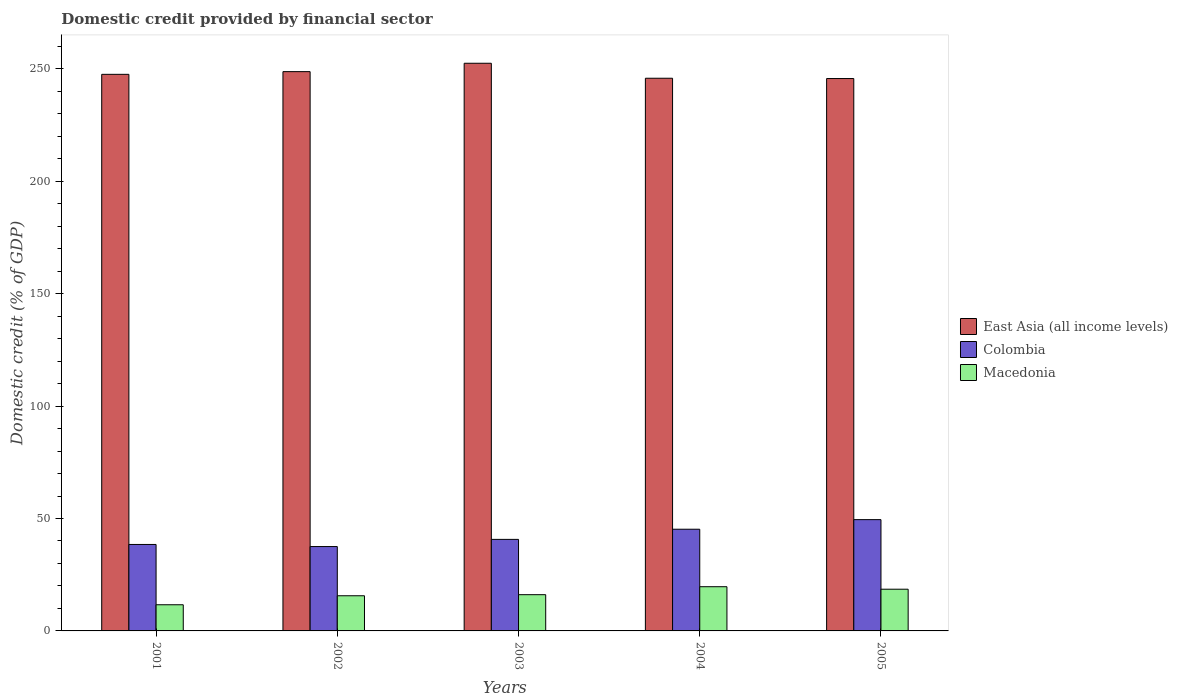Are the number of bars per tick equal to the number of legend labels?
Ensure brevity in your answer.  Yes. How many bars are there on the 2nd tick from the left?
Offer a very short reply. 3. How many bars are there on the 3rd tick from the right?
Give a very brief answer. 3. In how many cases, is the number of bars for a given year not equal to the number of legend labels?
Make the answer very short. 0. What is the domestic credit in East Asia (all income levels) in 2001?
Keep it short and to the point. 247.56. Across all years, what is the maximum domestic credit in Macedonia?
Provide a short and direct response. 19.66. Across all years, what is the minimum domestic credit in Colombia?
Your answer should be very brief. 37.53. What is the total domestic credit in East Asia (all income levels) in the graph?
Your response must be concise. 1240.33. What is the difference between the domestic credit in Macedonia in 2001 and that in 2002?
Offer a terse response. -4. What is the difference between the domestic credit in Macedonia in 2005 and the domestic credit in East Asia (all income levels) in 2002?
Your answer should be compact. -230.21. What is the average domestic credit in Macedonia per year?
Keep it short and to the point. 16.32. In the year 2004, what is the difference between the domestic credit in Colombia and domestic credit in East Asia (all income levels)?
Your answer should be compact. -200.59. What is the ratio of the domestic credit in Macedonia in 2002 to that in 2004?
Your response must be concise. 0.8. Is the domestic credit in East Asia (all income levels) in 2003 less than that in 2005?
Your answer should be very brief. No. What is the difference between the highest and the second highest domestic credit in Colombia?
Make the answer very short. 4.27. What is the difference between the highest and the lowest domestic credit in East Asia (all income levels)?
Your answer should be compact. 6.8. In how many years, is the domestic credit in East Asia (all income levels) greater than the average domestic credit in East Asia (all income levels) taken over all years?
Provide a short and direct response. 2. What does the 3rd bar from the left in 2003 represents?
Provide a short and direct response. Macedonia. What does the 1st bar from the right in 2004 represents?
Offer a terse response. Macedonia. Is it the case that in every year, the sum of the domestic credit in East Asia (all income levels) and domestic credit in Colombia is greater than the domestic credit in Macedonia?
Provide a short and direct response. Yes. How many bars are there?
Your answer should be very brief. 15. Are all the bars in the graph horizontal?
Your answer should be very brief. No. Are the values on the major ticks of Y-axis written in scientific E-notation?
Give a very brief answer. No. Does the graph contain any zero values?
Your response must be concise. No. How are the legend labels stacked?
Offer a very short reply. Vertical. What is the title of the graph?
Make the answer very short. Domestic credit provided by financial sector. Does "Nigeria" appear as one of the legend labels in the graph?
Keep it short and to the point. No. What is the label or title of the Y-axis?
Offer a very short reply. Domestic credit (% of GDP). What is the Domestic credit (% of GDP) in East Asia (all income levels) in 2001?
Your answer should be very brief. 247.56. What is the Domestic credit (% of GDP) of Colombia in 2001?
Provide a succinct answer. 38.46. What is the Domestic credit (% of GDP) of Macedonia in 2001?
Ensure brevity in your answer.  11.64. What is the Domestic credit (% of GDP) in East Asia (all income levels) in 2002?
Your answer should be compact. 248.76. What is the Domestic credit (% of GDP) in Colombia in 2002?
Your answer should be compact. 37.53. What is the Domestic credit (% of GDP) of Macedonia in 2002?
Your response must be concise. 15.64. What is the Domestic credit (% of GDP) of East Asia (all income levels) in 2003?
Keep it short and to the point. 252.49. What is the Domestic credit (% of GDP) of Colombia in 2003?
Offer a terse response. 40.72. What is the Domestic credit (% of GDP) of Macedonia in 2003?
Provide a short and direct response. 16.12. What is the Domestic credit (% of GDP) of East Asia (all income levels) in 2004?
Provide a short and direct response. 245.82. What is the Domestic credit (% of GDP) in Colombia in 2004?
Make the answer very short. 45.23. What is the Domestic credit (% of GDP) in Macedonia in 2004?
Your answer should be compact. 19.66. What is the Domestic credit (% of GDP) of East Asia (all income levels) in 2005?
Provide a succinct answer. 245.69. What is the Domestic credit (% of GDP) in Colombia in 2005?
Ensure brevity in your answer.  49.5. What is the Domestic credit (% of GDP) of Macedonia in 2005?
Keep it short and to the point. 18.55. Across all years, what is the maximum Domestic credit (% of GDP) in East Asia (all income levels)?
Provide a succinct answer. 252.49. Across all years, what is the maximum Domestic credit (% of GDP) in Colombia?
Make the answer very short. 49.5. Across all years, what is the maximum Domestic credit (% of GDP) of Macedonia?
Offer a terse response. 19.66. Across all years, what is the minimum Domestic credit (% of GDP) in East Asia (all income levels)?
Your response must be concise. 245.69. Across all years, what is the minimum Domestic credit (% of GDP) of Colombia?
Provide a short and direct response. 37.53. Across all years, what is the minimum Domestic credit (% of GDP) in Macedonia?
Ensure brevity in your answer.  11.64. What is the total Domestic credit (% of GDP) of East Asia (all income levels) in the graph?
Give a very brief answer. 1240.33. What is the total Domestic credit (% of GDP) in Colombia in the graph?
Offer a terse response. 211.44. What is the total Domestic credit (% of GDP) in Macedonia in the graph?
Keep it short and to the point. 81.62. What is the difference between the Domestic credit (% of GDP) in East Asia (all income levels) in 2001 and that in 2002?
Make the answer very short. -1.21. What is the difference between the Domestic credit (% of GDP) of Colombia in 2001 and that in 2002?
Provide a short and direct response. 0.93. What is the difference between the Domestic credit (% of GDP) in Macedonia in 2001 and that in 2002?
Offer a very short reply. -4. What is the difference between the Domestic credit (% of GDP) of East Asia (all income levels) in 2001 and that in 2003?
Make the answer very short. -4.93. What is the difference between the Domestic credit (% of GDP) in Colombia in 2001 and that in 2003?
Your response must be concise. -2.26. What is the difference between the Domestic credit (% of GDP) in Macedonia in 2001 and that in 2003?
Offer a very short reply. -4.48. What is the difference between the Domestic credit (% of GDP) of East Asia (all income levels) in 2001 and that in 2004?
Offer a very short reply. 1.74. What is the difference between the Domestic credit (% of GDP) of Colombia in 2001 and that in 2004?
Offer a very short reply. -6.78. What is the difference between the Domestic credit (% of GDP) in Macedonia in 2001 and that in 2004?
Provide a succinct answer. -8.02. What is the difference between the Domestic credit (% of GDP) of East Asia (all income levels) in 2001 and that in 2005?
Your answer should be compact. 1.87. What is the difference between the Domestic credit (% of GDP) in Colombia in 2001 and that in 2005?
Provide a short and direct response. -11.04. What is the difference between the Domestic credit (% of GDP) in Macedonia in 2001 and that in 2005?
Your response must be concise. -6.92. What is the difference between the Domestic credit (% of GDP) in East Asia (all income levels) in 2002 and that in 2003?
Make the answer very short. -3.72. What is the difference between the Domestic credit (% of GDP) in Colombia in 2002 and that in 2003?
Ensure brevity in your answer.  -3.19. What is the difference between the Domestic credit (% of GDP) of Macedonia in 2002 and that in 2003?
Make the answer very short. -0.48. What is the difference between the Domestic credit (% of GDP) in East Asia (all income levels) in 2002 and that in 2004?
Provide a short and direct response. 2.94. What is the difference between the Domestic credit (% of GDP) of Colombia in 2002 and that in 2004?
Make the answer very short. -7.71. What is the difference between the Domestic credit (% of GDP) in Macedonia in 2002 and that in 2004?
Your response must be concise. -4.02. What is the difference between the Domestic credit (% of GDP) of East Asia (all income levels) in 2002 and that in 2005?
Make the answer very short. 3.07. What is the difference between the Domestic credit (% of GDP) in Colombia in 2002 and that in 2005?
Ensure brevity in your answer.  -11.97. What is the difference between the Domestic credit (% of GDP) in Macedonia in 2002 and that in 2005?
Keep it short and to the point. -2.91. What is the difference between the Domestic credit (% of GDP) in East Asia (all income levels) in 2003 and that in 2004?
Make the answer very short. 6.67. What is the difference between the Domestic credit (% of GDP) of Colombia in 2003 and that in 2004?
Give a very brief answer. -4.52. What is the difference between the Domestic credit (% of GDP) in Macedonia in 2003 and that in 2004?
Keep it short and to the point. -3.54. What is the difference between the Domestic credit (% of GDP) in East Asia (all income levels) in 2003 and that in 2005?
Provide a short and direct response. 6.8. What is the difference between the Domestic credit (% of GDP) of Colombia in 2003 and that in 2005?
Provide a succinct answer. -8.79. What is the difference between the Domestic credit (% of GDP) in Macedonia in 2003 and that in 2005?
Ensure brevity in your answer.  -2.43. What is the difference between the Domestic credit (% of GDP) of East Asia (all income levels) in 2004 and that in 2005?
Offer a very short reply. 0.13. What is the difference between the Domestic credit (% of GDP) of Colombia in 2004 and that in 2005?
Offer a very short reply. -4.27. What is the difference between the Domestic credit (% of GDP) in Macedonia in 2004 and that in 2005?
Your answer should be very brief. 1.11. What is the difference between the Domestic credit (% of GDP) of East Asia (all income levels) in 2001 and the Domestic credit (% of GDP) of Colombia in 2002?
Give a very brief answer. 210.03. What is the difference between the Domestic credit (% of GDP) of East Asia (all income levels) in 2001 and the Domestic credit (% of GDP) of Macedonia in 2002?
Your answer should be compact. 231.92. What is the difference between the Domestic credit (% of GDP) in Colombia in 2001 and the Domestic credit (% of GDP) in Macedonia in 2002?
Offer a terse response. 22.82. What is the difference between the Domestic credit (% of GDP) of East Asia (all income levels) in 2001 and the Domestic credit (% of GDP) of Colombia in 2003?
Give a very brief answer. 206.84. What is the difference between the Domestic credit (% of GDP) in East Asia (all income levels) in 2001 and the Domestic credit (% of GDP) in Macedonia in 2003?
Offer a very short reply. 231.44. What is the difference between the Domestic credit (% of GDP) in Colombia in 2001 and the Domestic credit (% of GDP) in Macedonia in 2003?
Your response must be concise. 22.34. What is the difference between the Domestic credit (% of GDP) of East Asia (all income levels) in 2001 and the Domestic credit (% of GDP) of Colombia in 2004?
Give a very brief answer. 202.33. What is the difference between the Domestic credit (% of GDP) in East Asia (all income levels) in 2001 and the Domestic credit (% of GDP) in Macedonia in 2004?
Offer a terse response. 227.9. What is the difference between the Domestic credit (% of GDP) in Colombia in 2001 and the Domestic credit (% of GDP) in Macedonia in 2004?
Keep it short and to the point. 18.8. What is the difference between the Domestic credit (% of GDP) in East Asia (all income levels) in 2001 and the Domestic credit (% of GDP) in Colombia in 2005?
Offer a very short reply. 198.06. What is the difference between the Domestic credit (% of GDP) in East Asia (all income levels) in 2001 and the Domestic credit (% of GDP) in Macedonia in 2005?
Offer a terse response. 229. What is the difference between the Domestic credit (% of GDP) of Colombia in 2001 and the Domestic credit (% of GDP) of Macedonia in 2005?
Your response must be concise. 19.9. What is the difference between the Domestic credit (% of GDP) of East Asia (all income levels) in 2002 and the Domestic credit (% of GDP) of Colombia in 2003?
Your response must be concise. 208.05. What is the difference between the Domestic credit (% of GDP) in East Asia (all income levels) in 2002 and the Domestic credit (% of GDP) in Macedonia in 2003?
Provide a succinct answer. 232.64. What is the difference between the Domestic credit (% of GDP) of Colombia in 2002 and the Domestic credit (% of GDP) of Macedonia in 2003?
Your answer should be compact. 21.41. What is the difference between the Domestic credit (% of GDP) in East Asia (all income levels) in 2002 and the Domestic credit (% of GDP) in Colombia in 2004?
Keep it short and to the point. 203.53. What is the difference between the Domestic credit (% of GDP) in East Asia (all income levels) in 2002 and the Domestic credit (% of GDP) in Macedonia in 2004?
Ensure brevity in your answer.  229.1. What is the difference between the Domestic credit (% of GDP) in Colombia in 2002 and the Domestic credit (% of GDP) in Macedonia in 2004?
Ensure brevity in your answer.  17.87. What is the difference between the Domestic credit (% of GDP) of East Asia (all income levels) in 2002 and the Domestic credit (% of GDP) of Colombia in 2005?
Your answer should be compact. 199.26. What is the difference between the Domestic credit (% of GDP) in East Asia (all income levels) in 2002 and the Domestic credit (% of GDP) in Macedonia in 2005?
Ensure brevity in your answer.  230.21. What is the difference between the Domestic credit (% of GDP) of Colombia in 2002 and the Domestic credit (% of GDP) of Macedonia in 2005?
Your answer should be very brief. 18.97. What is the difference between the Domestic credit (% of GDP) of East Asia (all income levels) in 2003 and the Domestic credit (% of GDP) of Colombia in 2004?
Ensure brevity in your answer.  207.26. What is the difference between the Domestic credit (% of GDP) in East Asia (all income levels) in 2003 and the Domestic credit (% of GDP) in Macedonia in 2004?
Provide a succinct answer. 232.83. What is the difference between the Domestic credit (% of GDP) of Colombia in 2003 and the Domestic credit (% of GDP) of Macedonia in 2004?
Provide a short and direct response. 21.05. What is the difference between the Domestic credit (% of GDP) of East Asia (all income levels) in 2003 and the Domestic credit (% of GDP) of Colombia in 2005?
Offer a very short reply. 202.99. What is the difference between the Domestic credit (% of GDP) in East Asia (all income levels) in 2003 and the Domestic credit (% of GDP) in Macedonia in 2005?
Give a very brief answer. 233.93. What is the difference between the Domestic credit (% of GDP) of Colombia in 2003 and the Domestic credit (% of GDP) of Macedonia in 2005?
Provide a short and direct response. 22.16. What is the difference between the Domestic credit (% of GDP) of East Asia (all income levels) in 2004 and the Domestic credit (% of GDP) of Colombia in 2005?
Offer a very short reply. 196.32. What is the difference between the Domestic credit (% of GDP) in East Asia (all income levels) in 2004 and the Domestic credit (% of GDP) in Macedonia in 2005?
Provide a short and direct response. 227.27. What is the difference between the Domestic credit (% of GDP) in Colombia in 2004 and the Domestic credit (% of GDP) in Macedonia in 2005?
Provide a short and direct response. 26.68. What is the average Domestic credit (% of GDP) in East Asia (all income levels) per year?
Offer a very short reply. 248.07. What is the average Domestic credit (% of GDP) in Colombia per year?
Your answer should be very brief. 42.29. What is the average Domestic credit (% of GDP) in Macedonia per year?
Keep it short and to the point. 16.32. In the year 2001, what is the difference between the Domestic credit (% of GDP) of East Asia (all income levels) and Domestic credit (% of GDP) of Colombia?
Ensure brevity in your answer.  209.1. In the year 2001, what is the difference between the Domestic credit (% of GDP) of East Asia (all income levels) and Domestic credit (% of GDP) of Macedonia?
Your response must be concise. 235.92. In the year 2001, what is the difference between the Domestic credit (% of GDP) in Colombia and Domestic credit (% of GDP) in Macedonia?
Offer a very short reply. 26.82. In the year 2002, what is the difference between the Domestic credit (% of GDP) of East Asia (all income levels) and Domestic credit (% of GDP) of Colombia?
Ensure brevity in your answer.  211.24. In the year 2002, what is the difference between the Domestic credit (% of GDP) in East Asia (all income levels) and Domestic credit (% of GDP) in Macedonia?
Provide a short and direct response. 233.12. In the year 2002, what is the difference between the Domestic credit (% of GDP) of Colombia and Domestic credit (% of GDP) of Macedonia?
Make the answer very short. 21.89. In the year 2003, what is the difference between the Domestic credit (% of GDP) in East Asia (all income levels) and Domestic credit (% of GDP) in Colombia?
Ensure brevity in your answer.  211.77. In the year 2003, what is the difference between the Domestic credit (% of GDP) in East Asia (all income levels) and Domestic credit (% of GDP) in Macedonia?
Your answer should be compact. 236.37. In the year 2003, what is the difference between the Domestic credit (% of GDP) in Colombia and Domestic credit (% of GDP) in Macedonia?
Provide a short and direct response. 24.6. In the year 2004, what is the difference between the Domestic credit (% of GDP) in East Asia (all income levels) and Domestic credit (% of GDP) in Colombia?
Provide a succinct answer. 200.59. In the year 2004, what is the difference between the Domestic credit (% of GDP) in East Asia (all income levels) and Domestic credit (% of GDP) in Macedonia?
Keep it short and to the point. 226.16. In the year 2004, what is the difference between the Domestic credit (% of GDP) of Colombia and Domestic credit (% of GDP) of Macedonia?
Make the answer very short. 25.57. In the year 2005, what is the difference between the Domestic credit (% of GDP) of East Asia (all income levels) and Domestic credit (% of GDP) of Colombia?
Your answer should be very brief. 196.19. In the year 2005, what is the difference between the Domestic credit (% of GDP) in East Asia (all income levels) and Domestic credit (% of GDP) in Macedonia?
Your answer should be very brief. 227.14. In the year 2005, what is the difference between the Domestic credit (% of GDP) of Colombia and Domestic credit (% of GDP) of Macedonia?
Your answer should be very brief. 30.95. What is the ratio of the Domestic credit (% of GDP) of Colombia in 2001 to that in 2002?
Provide a succinct answer. 1.02. What is the ratio of the Domestic credit (% of GDP) of Macedonia in 2001 to that in 2002?
Your answer should be very brief. 0.74. What is the ratio of the Domestic credit (% of GDP) of East Asia (all income levels) in 2001 to that in 2003?
Your answer should be very brief. 0.98. What is the ratio of the Domestic credit (% of GDP) of Colombia in 2001 to that in 2003?
Make the answer very short. 0.94. What is the ratio of the Domestic credit (% of GDP) in Macedonia in 2001 to that in 2003?
Your answer should be compact. 0.72. What is the ratio of the Domestic credit (% of GDP) in East Asia (all income levels) in 2001 to that in 2004?
Keep it short and to the point. 1.01. What is the ratio of the Domestic credit (% of GDP) of Colombia in 2001 to that in 2004?
Offer a terse response. 0.85. What is the ratio of the Domestic credit (% of GDP) in Macedonia in 2001 to that in 2004?
Offer a very short reply. 0.59. What is the ratio of the Domestic credit (% of GDP) in East Asia (all income levels) in 2001 to that in 2005?
Give a very brief answer. 1.01. What is the ratio of the Domestic credit (% of GDP) in Colombia in 2001 to that in 2005?
Your answer should be compact. 0.78. What is the ratio of the Domestic credit (% of GDP) of Macedonia in 2001 to that in 2005?
Your answer should be compact. 0.63. What is the ratio of the Domestic credit (% of GDP) of East Asia (all income levels) in 2002 to that in 2003?
Provide a short and direct response. 0.99. What is the ratio of the Domestic credit (% of GDP) of Colombia in 2002 to that in 2003?
Ensure brevity in your answer.  0.92. What is the ratio of the Domestic credit (% of GDP) of Macedonia in 2002 to that in 2003?
Ensure brevity in your answer.  0.97. What is the ratio of the Domestic credit (% of GDP) in East Asia (all income levels) in 2002 to that in 2004?
Keep it short and to the point. 1.01. What is the ratio of the Domestic credit (% of GDP) of Colombia in 2002 to that in 2004?
Your response must be concise. 0.83. What is the ratio of the Domestic credit (% of GDP) in Macedonia in 2002 to that in 2004?
Your answer should be compact. 0.8. What is the ratio of the Domestic credit (% of GDP) in East Asia (all income levels) in 2002 to that in 2005?
Give a very brief answer. 1.01. What is the ratio of the Domestic credit (% of GDP) in Colombia in 2002 to that in 2005?
Your answer should be very brief. 0.76. What is the ratio of the Domestic credit (% of GDP) in Macedonia in 2002 to that in 2005?
Ensure brevity in your answer.  0.84. What is the ratio of the Domestic credit (% of GDP) of East Asia (all income levels) in 2003 to that in 2004?
Make the answer very short. 1.03. What is the ratio of the Domestic credit (% of GDP) of Colombia in 2003 to that in 2004?
Offer a terse response. 0.9. What is the ratio of the Domestic credit (% of GDP) of Macedonia in 2003 to that in 2004?
Your answer should be very brief. 0.82. What is the ratio of the Domestic credit (% of GDP) in East Asia (all income levels) in 2003 to that in 2005?
Your answer should be very brief. 1.03. What is the ratio of the Domestic credit (% of GDP) of Colombia in 2003 to that in 2005?
Your answer should be very brief. 0.82. What is the ratio of the Domestic credit (% of GDP) in Macedonia in 2003 to that in 2005?
Your response must be concise. 0.87. What is the ratio of the Domestic credit (% of GDP) of East Asia (all income levels) in 2004 to that in 2005?
Make the answer very short. 1. What is the ratio of the Domestic credit (% of GDP) in Colombia in 2004 to that in 2005?
Ensure brevity in your answer.  0.91. What is the ratio of the Domestic credit (% of GDP) of Macedonia in 2004 to that in 2005?
Offer a terse response. 1.06. What is the difference between the highest and the second highest Domestic credit (% of GDP) in East Asia (all income levels)?
Keep it short and to the point. 3.72. What is the difference between the highest and the second highest Domestic credit (% of GDP) in Colombia?
Your answer should be very brief. 4.27. What is the difference between the highest and the second highest Domestic credit (% of GDP) of Macedonia?
Provide a short and direct response. 1.11. What is the difference between the highest and the lowest Domestic credit (% of GDP) in East Asia (all income levels)?
Provide a succinct answer. 6.8. What is the difference between the highest and the lowest Domestic credit (% of GDP) in Colombia?
Provide a succinct answer. 11.97. What is the difference between the highest and the lowest Domestic credit (% of GDP) of Macedonia?
Give a very brief answer. 8.02. 